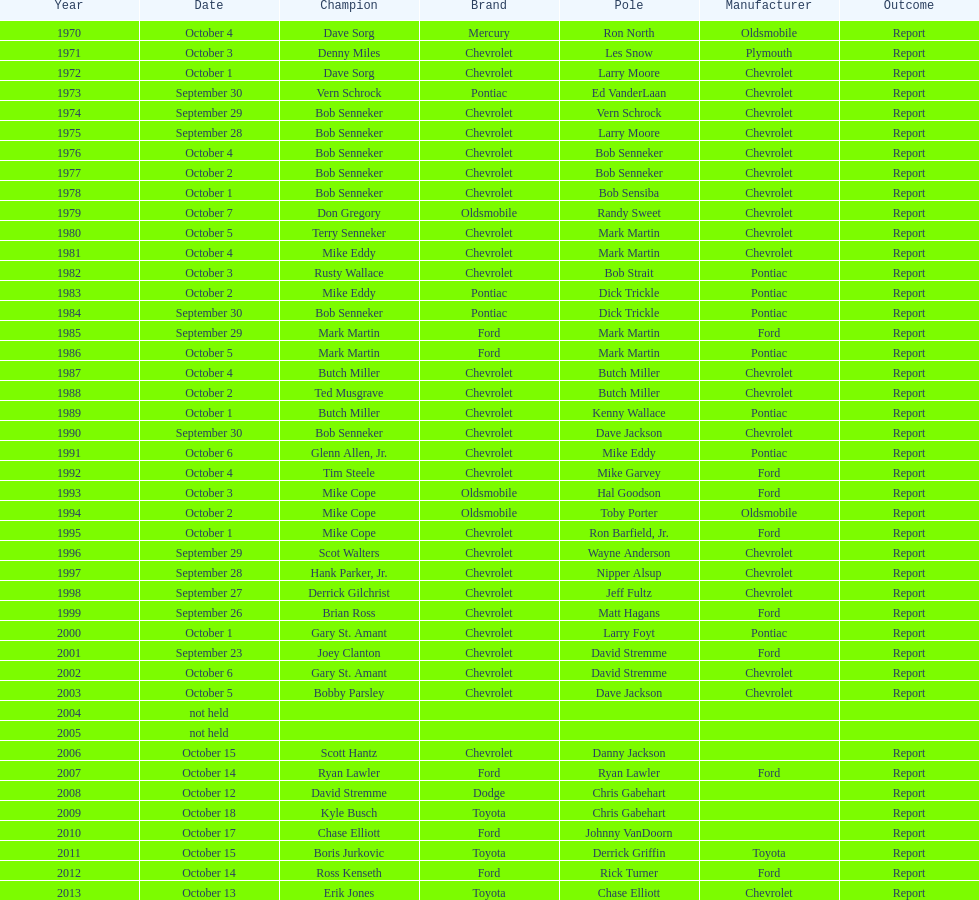Who on the list has the highest number of consecutive wins? Bob Senneker. 